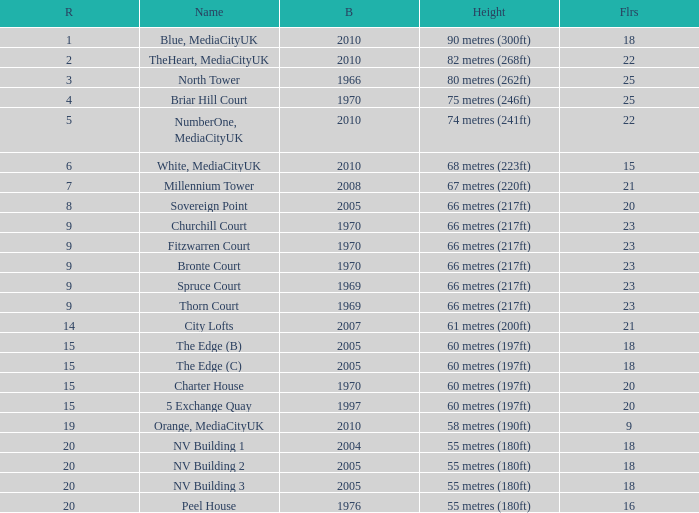What is Height, when Rank is less than 20, when Floors is greater than 9, when Built is 2005, and when Name is The Edge (C)? 60 metres (197ft). 